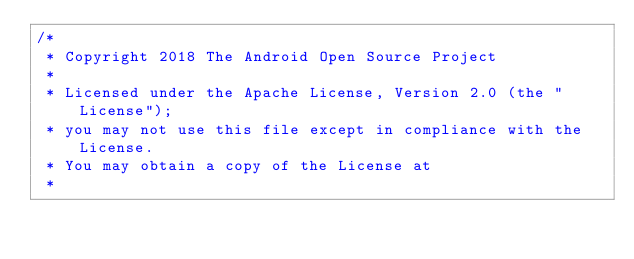Convert code to text. <code><loc_0><loc_0><loc_500><loc_500><_Kotlin_>/*
 * Copyright 2018 The Android Open Source Project
 *
 * Licensed under the Apache License, Version 2.0 (the "License");
 * you may not use this file except in compliance with the License.
 * You may obtain a copy of the License at
 *</code> 